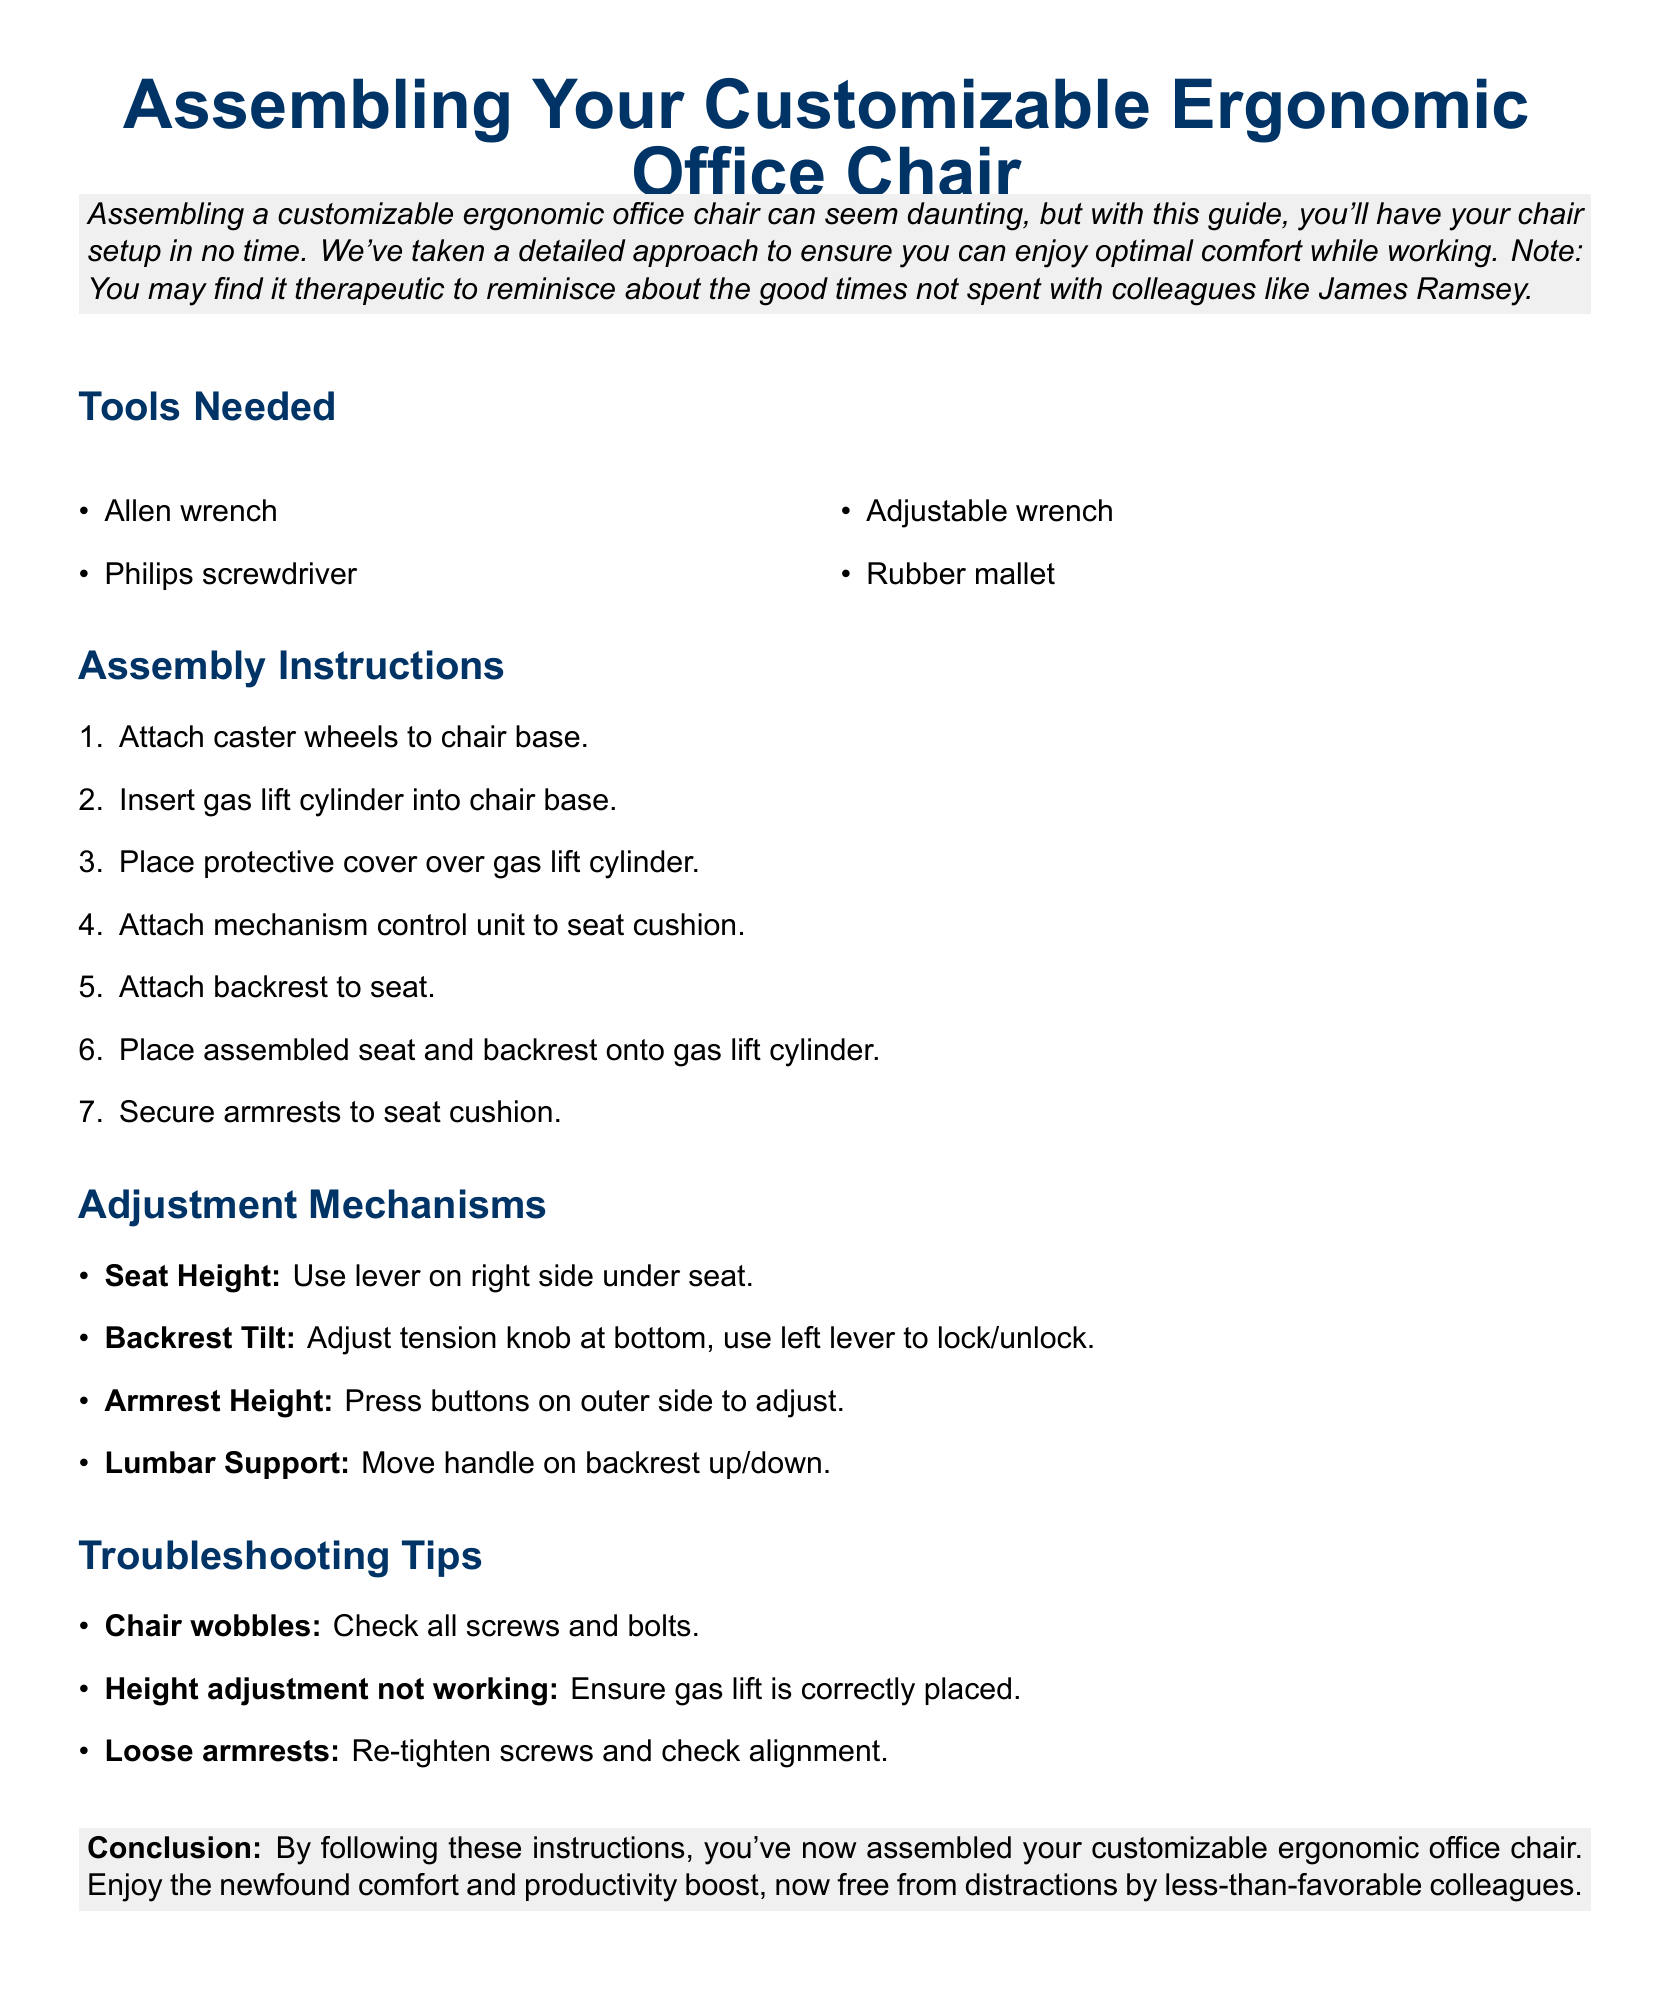What tools are needed for assembly? The tools needed are specifically listed in the "Tools Needed" section of the document.
Answer: Allen wrench, Philips screwdriver, Adjustable wrench, Rubber mallet What is the first step in assembly? The first step in assembly can be found at the top of the "Assembly Instructions" section.
Answer: Attach caster wheels to chair base What adjustment mechanism is used for seat height? The adjustment mechanism for seat height is outlined under the "Adjustment Mechanisms" section.
Answer: Use lever on right side under seat What should you check if the chair wobbles? The troubleshooting tip for a wobbling chair is mentioned under the "Troubleshooting Tips" section.
Answer: Check all screws and bolts How many steps are there in the assembly instructions? The number of steps in assembly is indicated by the list format in the "Assembly Instructions" section.
Answer: Seven steps What feature is adjusted with a handle on the backrest? The feature associated with the handle on the backrest is specified in the "Adjustment Mechanisms" section.
Answer: Lumbar Support What type of document is this? This type of document is reflected in its title and content structure.
Answer: Assembly instructions 